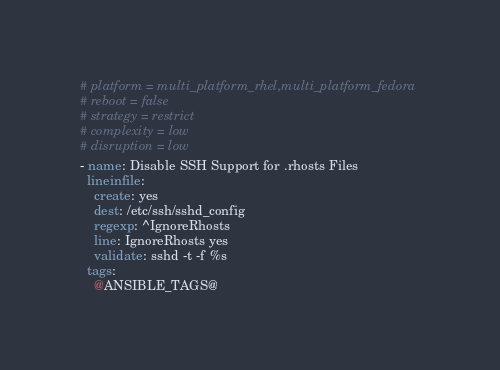Convert code to text. <code><loc_0><loc_0><loc_500><loc_500><_YAML_># platform = multi_platform_rhel,multi_platform_fedora
# reboot = false
# strategy = restrict
# complexity = low
# disruption = low
- name: Disable SSH Support for .rhosts Files
  lineinfile:
    create: yes
    dest: /etc/ssh/sshd_config
    regexp: ^IgnoreRhosts
    line: IgnoreRhosts yes
    validate: sshd -t -f %s
  tags:
    @ANSIBLE_TAGS@
</code> 